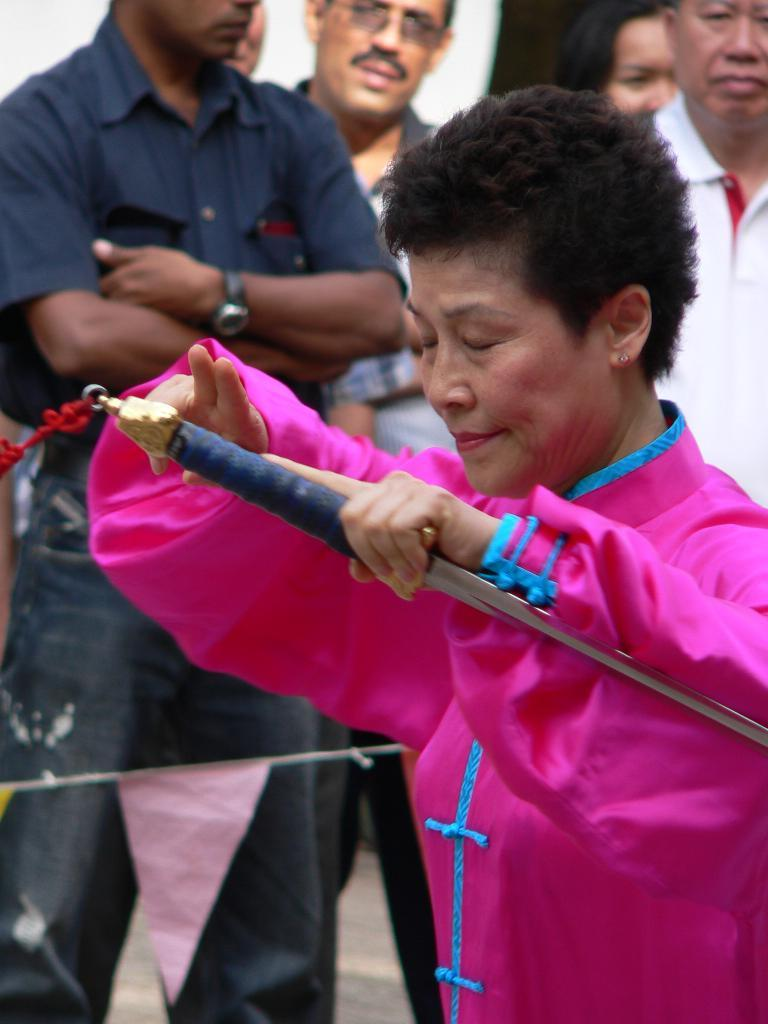Who is the main subject in the image? There is a woman in the image. What is the woman wearing? The woman is wearing a pink dress. What is the woman holding in the image? The woman is holding a sword. Can you describe the people in the background of the image? There are people standing in the background of the image. What is the paper flag at the bottom of the image? There is a paper flag at the bottom of the image. What type of nut is the woman cracking open with the sword in the image? There is no nut present in the image, and the woman is not using the sword to crack open a nut. 